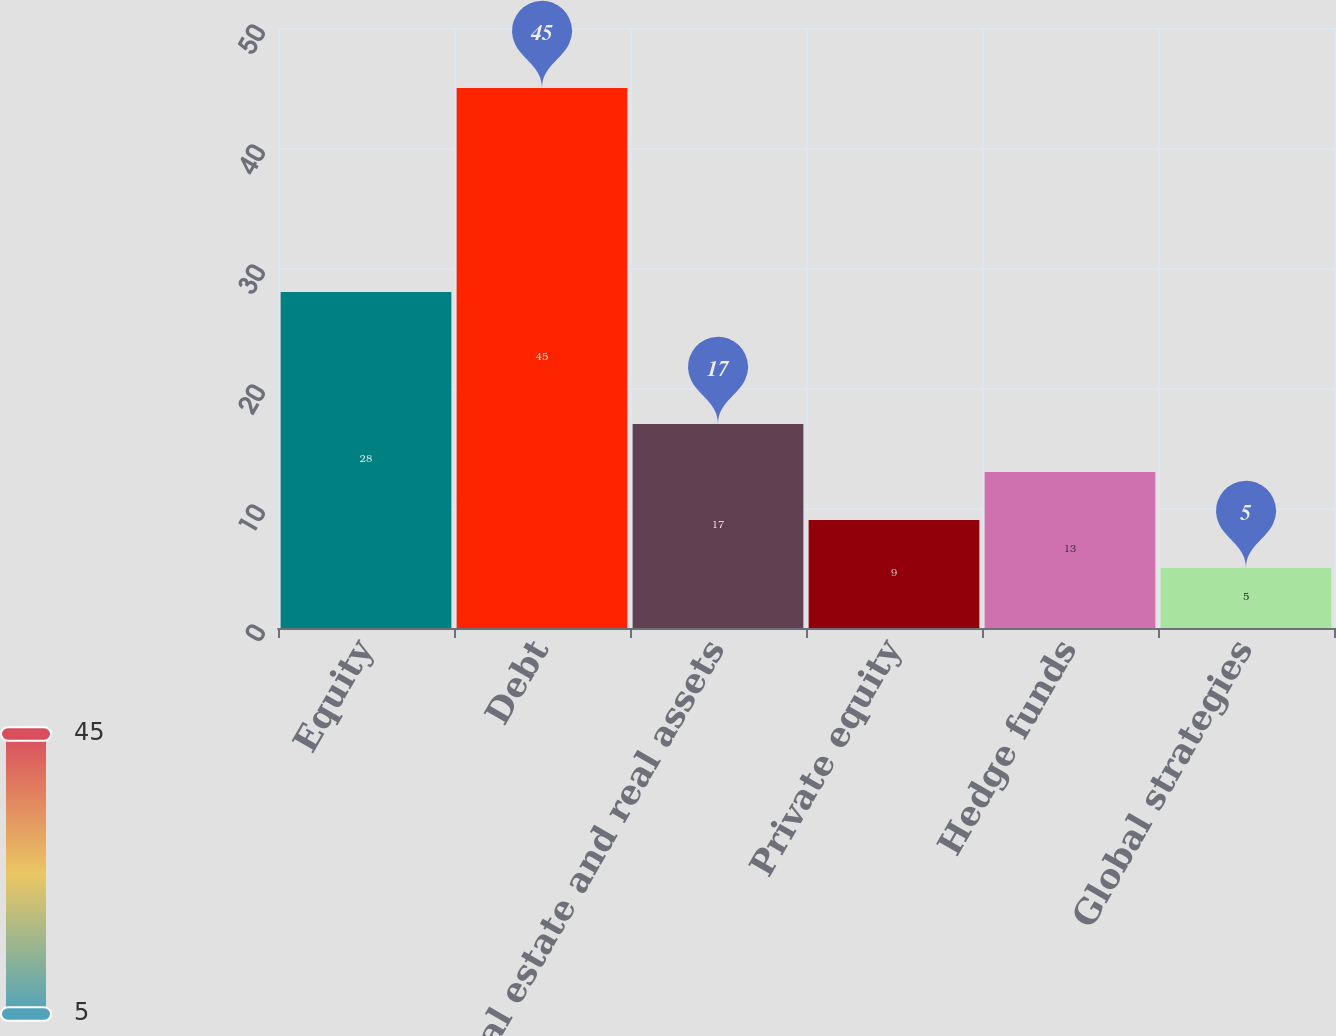Convert chart. <chart><loc_0><loc_0><loc_500><loc_500><bar_chart><fcel>Equity<fcel>Debt<fcel>Real estate and real assets<fcel>Private equity<fcel>Hedge funds<fcel>Global strategies<nl><fcel>28<fcel>45<fcel>17<fcel>9<fcel>13<fcel>5<nl></chart> 